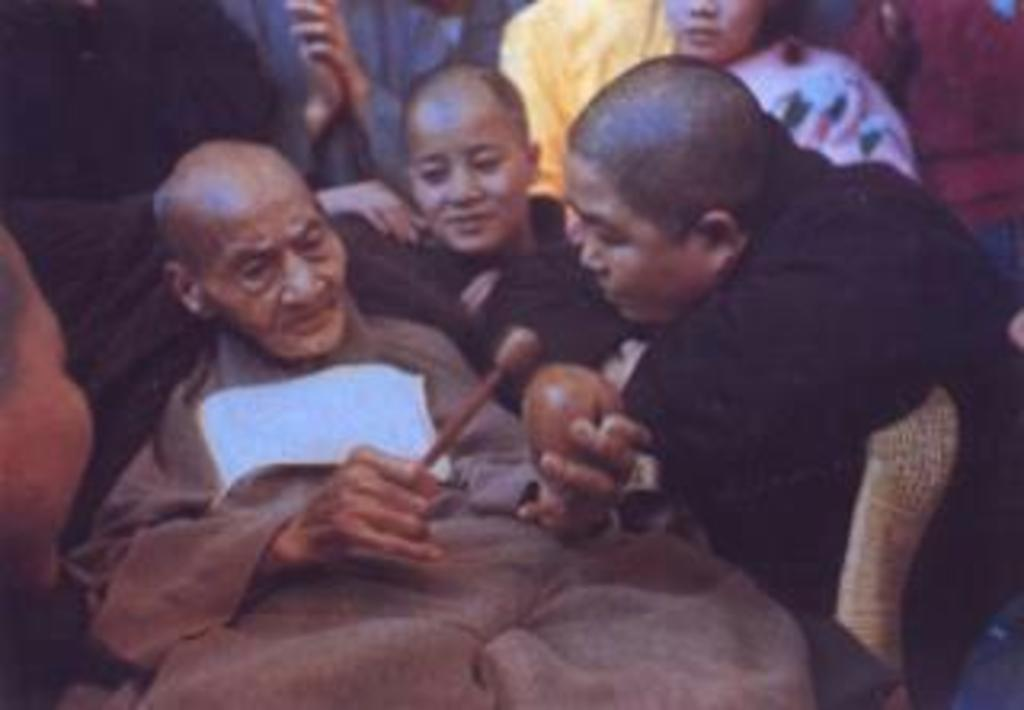Who is the main subject in the image? There is a man in the center of the image. What is the man doing in the image? The man is lying down. What is the man holding in the image? The man is holding a musical instrument. Can you describe the people in the background of the image? There is a group of people in the background of the image. What type of steel is visible in the image? There is no steel present in the image. What position is the man in the image? The man is lying down in the image. 